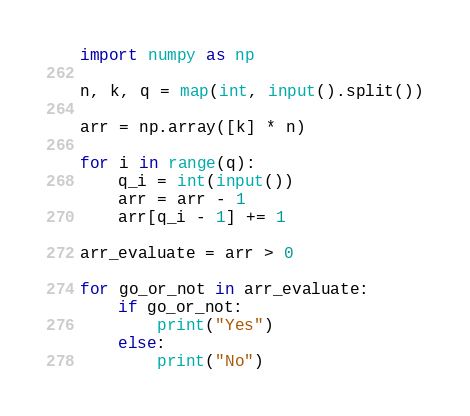<code> <loc_0><loc_0><loc_500><loc_500><_Python_>import numpy as np

n, k, q = map(int, input().split())

arr = np.array([k] * n)

for i in range(q):
    q_i = int(input())
    arr = arr - 1
    arr[q_i - 1] += 1

arr_evaluate = arr > 0

for go_or_not in arr_evaluate:
    if go_or_not:
        print("Yes")
    else:
        print("No")

</code> 